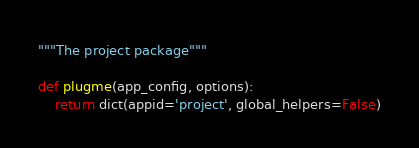Convert code to text. <code><loc_0><loc_0><loc_500><loc_500><_Python_>"""The project package"""

def plugme(app_config, options):
    return dict(appid='project', global_helpers=False)</code> 